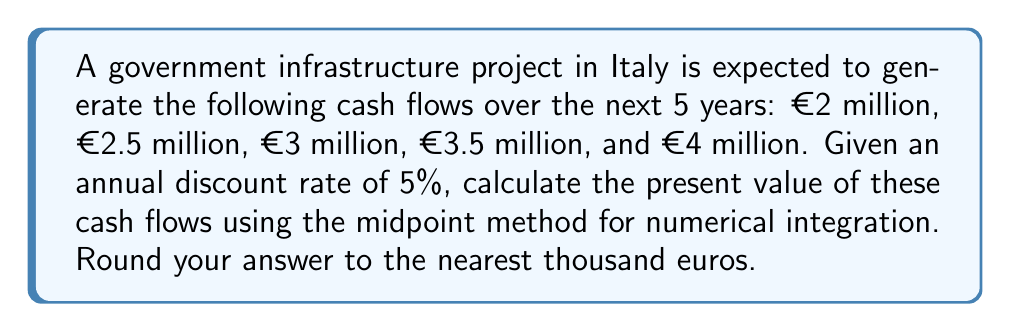Solve this math problem. To solve this problem, we'll use the midpoint method for numerical integration to approximate the present value of the cash flows. The steps are as follows:

1) The general formula for present value is:

   $$ PV = \sum_{t=1}^{n} \frac{CF_t}{(1+r)^t} $$

   where $CF_t$ is the cash flow at time $t$, $r$ is the discount rate, and $n$ is the number of periods.

2) We can view this as an integral and approximate it using the midpoint method:

   $$ PV \approx \sum_{i=1}^{n} f(x_i) \Delta x $$

   where $f(x) = \frac{CF(x)}{(1+r)^x}$, $x_i$ is the midpoint of each interval, and $\Delta x = 1$ (one year intervals).

3) Calculate the midpoints and corresponding cash flows:
   Year 0.5: €2 million
   Year 1.5: €2.5 million
   Year 2.5: €3 million
   Year 3.5: €3.5 million
   Year 4.5: €4 million

4) Apply the midpoint formula:

   $$ PV \approx \frac{2}{(1.05)^{0.5}} + \frac{2.5}{(1.05)^{1.5}} + \frac{3}{(1.05)^{2.5}} + \frac{3.5}{(1.05)^{3.5}} + \frac{4}{(1.05)^{4.5}} $$

5) Calculate each term:
   1.9512 + 2.3270 + 2.6574 + 2.9461 + 3.2000

6) Sum the terms:
   13.0817 million euros

7) Round to the nearest thousand:
   13,082,000 euros
Answer: €13,082,000 